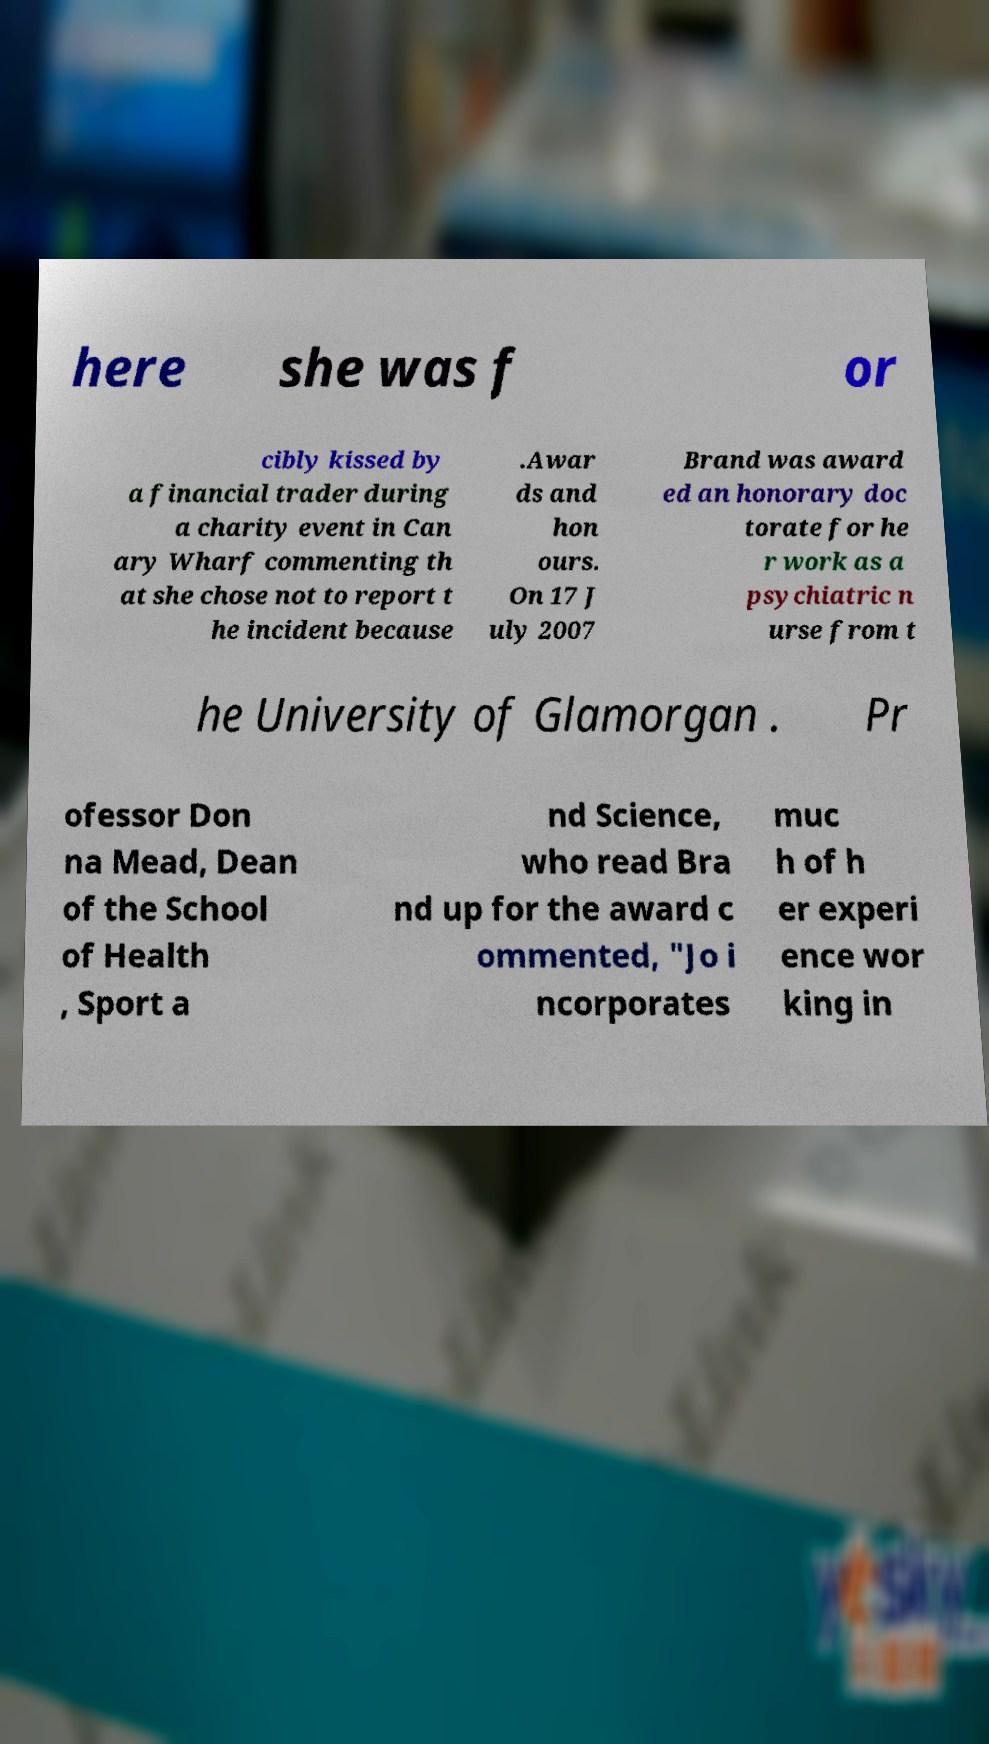Can you read and provide the text displayed in the image?This photo seems to have some interesting text. Can you extract and type it out for me? here she was f or cibly kissed by a financial trader during a charity event in Can ary Wharf commenting th at she chose not to report t he incident because .Awar ds and hon ours. On 17 J uly 2007 Brand was award ed an honorary doc torate for he r work as a psychiatric n urse from t he University of Glamorgan . Pr ofessor Don na Mead, Dean of the School of Health , Sport a nd Science, who read Bra nd up for the award c ommented, "Jo i ncorporates muc h of h er experi ence wor king in 